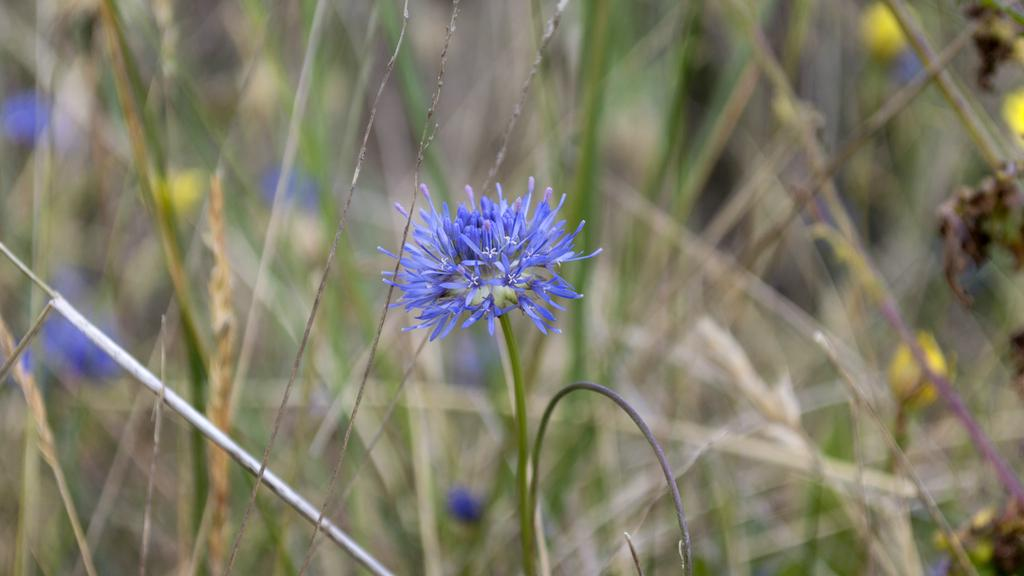What is the main subject in the center of the image? There is a flower in the center of the image. What else can be seen in the background of the image? Plants and flowers are visible in the background of the image. How does the son interact with the kittens in the image? There are no kittens or a son present in the image; it only features a flower and plants in the background. 